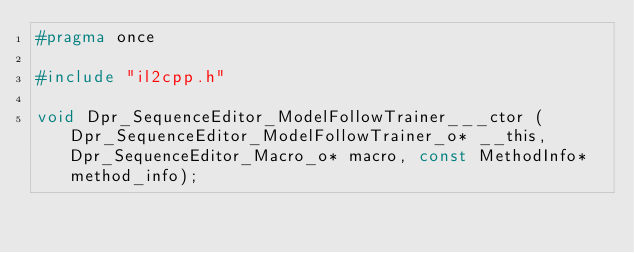<code> <loc_0><loc_0><loc_500><loc_500><_C_>#pragma once

#include "il2cpp.h"

void Dpr_SequenceEditor_ModelFollowTrainer___ctor (Dpr_SequenceEditor_ModelFollowTrainer_o* __this, Dpr_SequenceEditor_Macro_o* macro, const MethodInfo* method_info);
</code> 